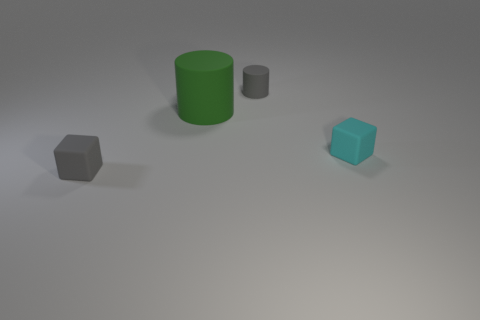There is a thing that is the same color as the tiny rubber cylinder; what is its size?
Provide a short and direct response. Small. Do the cube that is right of the big cylinder and the small gray cube have the same material?
Keep it short and to the point. Yes. Is there a big matte cylinder of the same color as the tiny rubber cylinder?
Provide a short and direct response. No. Does the tiny matte object that is left of the big object have the same shape as the tiny gray matte thing to the right of the large rubber thing?
Offer a very short reply. No. Is there a small purple cylinder made of the same material as the small cyan cube?
Keep it short and to the point. No. What number of blue objects are either small matte blocks or cylinders?
Offer a very short reply. 0. There is a thing that is both in front of the big green matte object and to the left of the tiny gray cylinder; how big is it?
Provide a succinct answer. Small. Are there more small gray matte objects in front of the tiny cyan block than tiny gray blocks?
Provide a short and direct response. No. What number of cylinders are tiny blue metallic things or large matte objects?
Your answer should be very brief. 1. What shape is the thing that is in front of the gray cylinder and behind the tiny cyan rubber thing?
Make the answer very short. Cylinder. 